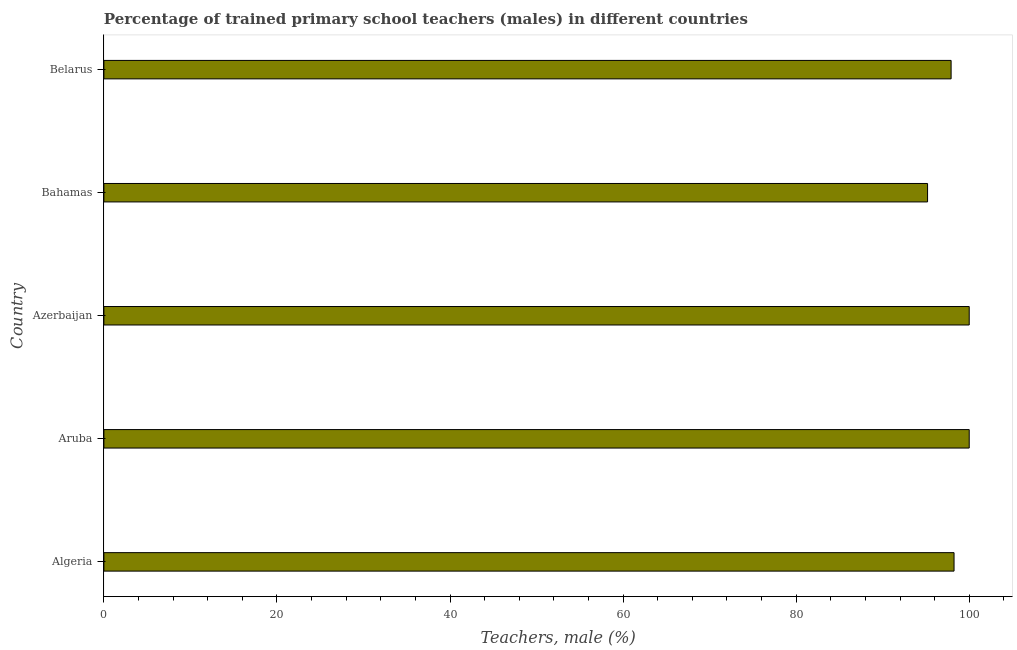Does the graph contain any zero values?
Your answer should be compact. No. What is the title of the graph?
Give a very brief answer. Percentage of trained primary school teachers (males) in different countries. What is the label or title of the X-axis?
Your response must be concise. Teachers, male (%). What is the percentage of trained male teachers in Algeria?
Your answer should be compact. 98.25. Across all countries, what is the maximum percentage of trained male teachers?
Your response must be concise. 100. Across all countries, what is the minimum percentage of trained male teachers?
Your response must be concise. 95.19. In which country was the percentage of trained male teachers maximum?
Ensure brevity in your answer.  Aruba. In which country was the percentage of trained male teachers minimum?
Offer a very short reply. Bahamas. What is the sum of the percentage of trained male teachers?
Offer a terse response. 491.34. What is the difference between the percentage of trained male teachers in Algeria and Bahamas?
Offer a very short reply. 3.06. What is the average percentage of trained male teachers per country?
Your answer should be compact. 98.27. What is the median percentage of trained male teachers?
Offer a very short reply. 98.25. In how many countries, is the percentage of trained male teachers greater than 44 %?
Keep it short and to the point. 5. Is the difference between the percentage of trained male teachers in Algeria and Azerbaijan greater than the difference between any two countries?
Keep it short and to the point. No. Is the sum of the percentage of trained male teachers in Algeria and Bahamas greater than the maximum percentage of trained male teachers across all countries?
Your answer should be compact. Yes. What is the difference between the highest and the lowest percentage of trained male teachers?
Offer a very short reply. 4.81. How many bars are there?
Your response must be concise. 5. Are all the bars in the graph horizontal?
Make the answer very short. Yes. How many countries are there in the graph?
Provide a succinct answer. 5. Are the values on the major ticks of X-axis written in scientific E-notation?
Your response must be concise. No. What is the Teachers, male (%) of Algeria?
Your response must be concise. 98.25. What is the Teachers, male (%) in Azerbaijan?
Offer a terse response. 100. What is the Teachers, male (%) in Bahamas?
Offer a very short reply. 95.19. What is the Teachers, male (%) in Belarus?
Provide a succinct answer. 97.91. What is the difference between the Teachers, male (%) in Algeria and Aruba?
Offer a very short reply. -1.75. What is the difference between the Teachers, male (%) in Algeria and Azerbaijan?
Your answer should be compact. -1.75. What is the difference between the Teachers, male (%) in Algeria and Bahamas?
Offer a terse response. 3.06. What is the difference between the Teachers, male (%) in Algeria and Belarus?
Give a very brief answer. 0.34. What is the difference between the Teachers, male (%) in Aruba and Azerbaijan?
Your answer should be compact. 0. What is the difference between the Teachers, male (%) in Aruba and Bahamas?
Give a very brief answer. 4.81. What is the difference between the Teachers, male (%) in Aruba and Belarus?
Ensure brevity in your answer.  2.09. What is the difference between the Teachers, male (%) in Azerbaijan and Bahamas?
Provide a short and direct response. 4.81. What is the difference between the Teachers, male (%) in Azerbaijan and Belarus?
Provide a short and direct response. 2.09. What is the difference between the Teachers, male (%) in Bahamas and Belarus?
Ensure brevity in your answer.  -2.72. What is the ratio of the Teachers, male (%) in Algeria to that in Aruba?
Offer a terse response. 0.98. What is the ratio of the Teachers, male (%) in Algeria to that in Bahamas?
Your answer should be compact. 1.03. What is the ratio of the Teachers, male (%) in Algeria to that in Belarus?
Make the answer very short. 1. What is the ratio of the Teachers, male (%) in Aruba to that in Azerbaijan?
Make the answer very short. 1. What is the ratio of the Teachers, male (%) in Aruba to that in Bahamas?
Keep it short and to the point. 1.05. What is the ratio of the Teachers, male (%) in Azerbaijan to that in Bahamas?
Provide a succinct answer. 1.05. What is the ratio of the Teachers, male (%) in Azerbaijan to that in Belarus?
Give a very brief answer. 1.02. 